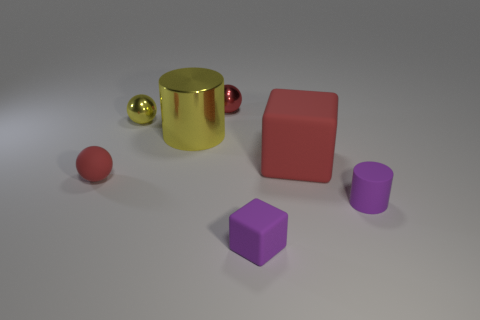Add 3 large yellow metal things. How many objects exist? 10 Subtract all cylinders. How many objects are left? 5 Add 4 tiny yellow metal balls. How many tiny yellow metal balls are left? 5 Add 6 small shiny things. How many small shiny things exist? 8 Subtract 0 blue cubes. How many objects are left? 7 Subtract all gray spheres. Subtract all yellow cylinders. How many objects are left? 6 